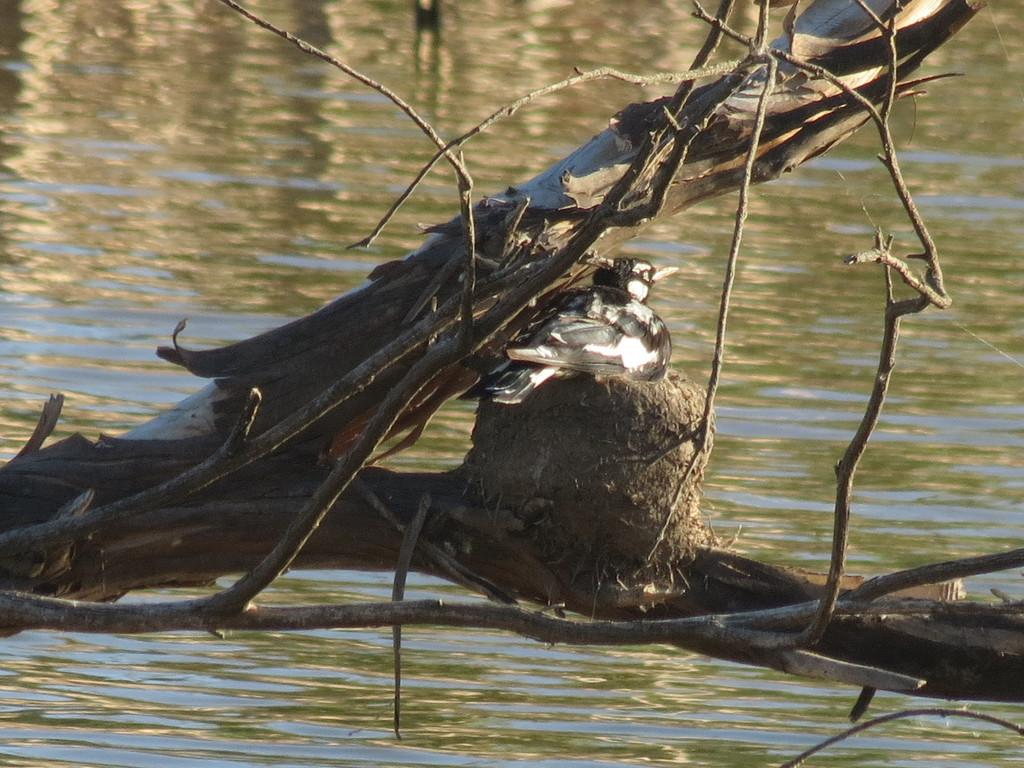What type of animal can be seen in the image? There is a bird in the image. Where is the bird located? The bird is sitting on a tree branch. What can be seen in the background of the image? There is water visible in the background of the image. How many ladybugs are crawling on the floor in the image? There are no ladybugs or floors present in the image; it features a bird sitting on a tree branch with water visible in the background. 